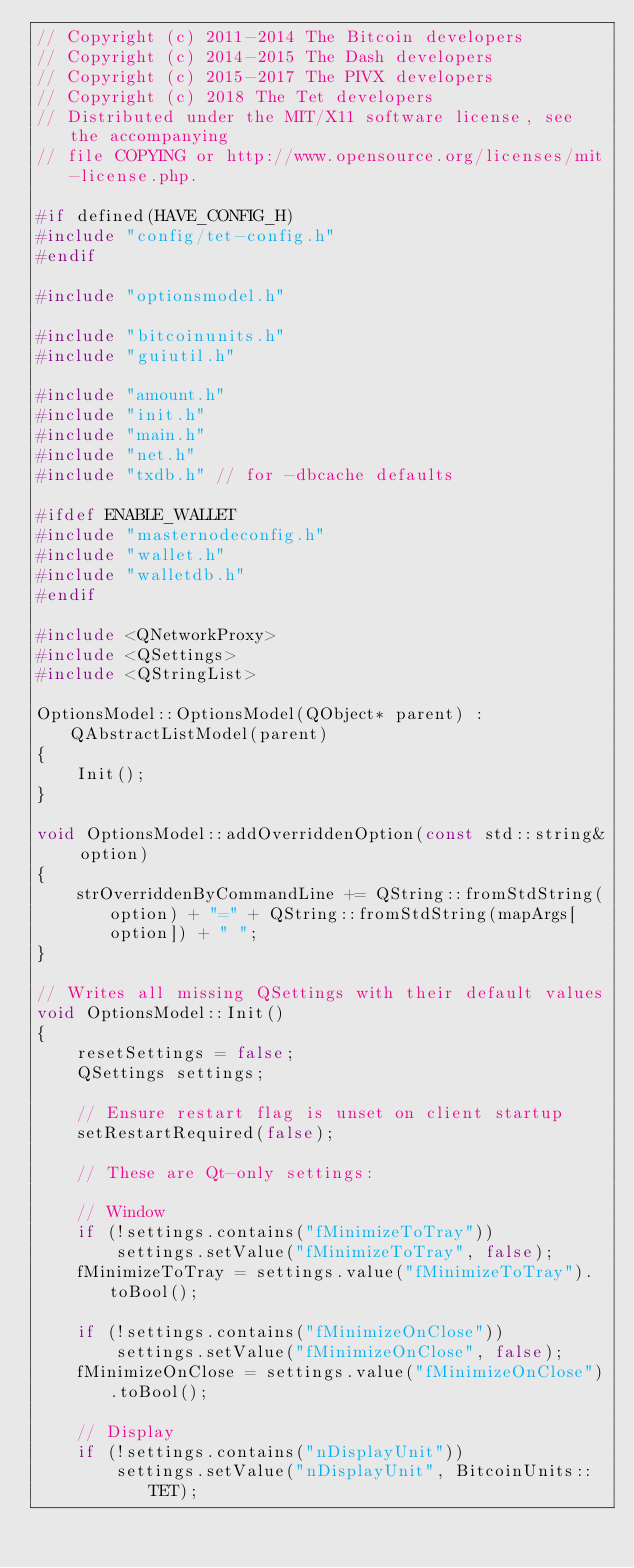<code> <loc_0><loc_0><loc_500><loc_500><_C++_>// Copyright (c) 2011-2014 The Bitcoin developers
// Copyright (c) 2014-2015 The Dash developers
// Copyright (c) 2015-2017 The PIVX developers
// Copyright (c) 2018 The Tet developers
// Distributed under the MIT/X11 software license, see the accompanying
// file COPYING or http://www.opensource.org/licenses/mit-license.php.

#if defined(HAVE_CONFIG_H)
#include "config/tet-config.h"
#endif

#include "optionsmodel.h"

#include "bitcoinunits.h"
#include "guiutil.h"

#include "amount.h"
#include "init.h"
#include "main.h"
#include "net.h"
#include "txdb.h" // for -dbcache defaults

#ifdef ENABLE_WALLET
#include "masternodeconfig.h"
#include "wallet.h"
#include "walletdb.h"
#endif

#include <QNetworkProxy>
#include <QSettings>
#include <QStringList>

OptionsModel::OptionsModel(QObject* parent) : QAbstractListModel(parent)
{
    Init();
}

void OptionsModel::addOverriddenOption(const std::string& option)
{
    strOverriddenByCommandLine += QString::fromStdString(option) + "=" + QString::fromStdString(mapArgs[option]) + " ";
}

// Writes all missing QSettings with their default values
void OptionsModel::Init()
{
    resetSettings = false;
    QSettings settings;

    // Ensure restart flag is unset on client startup
    setRestartRequired(false);

    // These are Qt-only settings:

    // Window
    if (!settings.contains("fMinimizeToTray"))
        settings.setValue("fMinimizeToTray", false);
    fMinimizeToTray = settings.value("fMinimizeToTray").toBool();

    if (!settings.contains("fMinimizeOnClose"))
        settings.setValue("fMinimizeOnClose", false);
    fMinimizeOnClose = settings.value("fMinimizeOnClose").toBool();

    // Display
    if (!settings.contains("nDisplayUnit"))
        settings.setValue("nDisplayUnit", BitcoinUnits::TET);</code> 